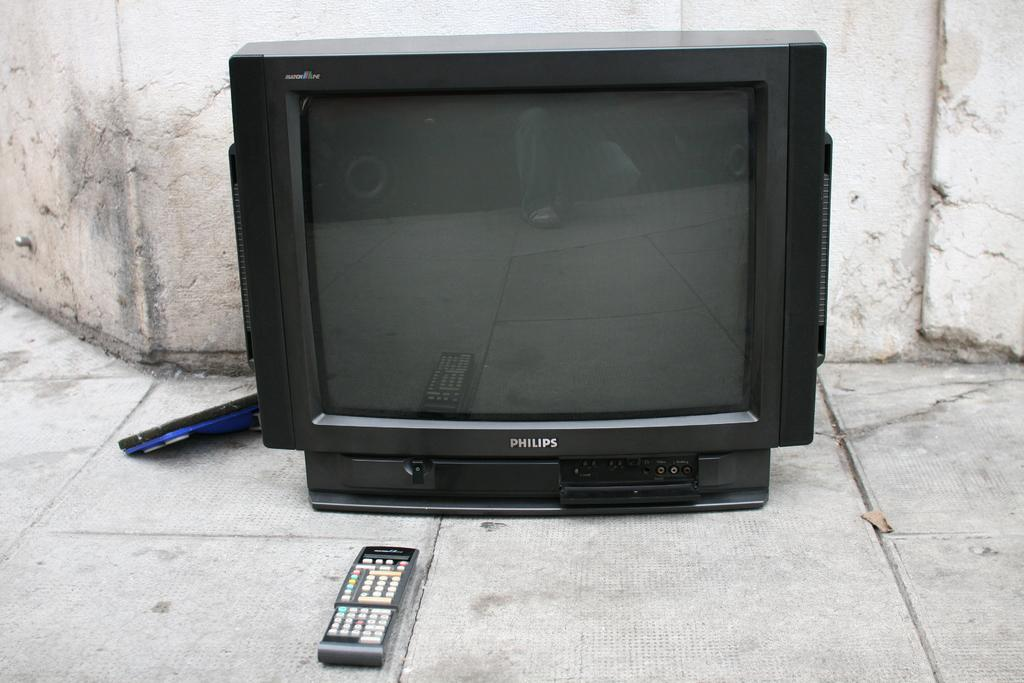<image>
Offer a succinct explanation of the picture presented. A MATCHLINE PHILIPS TV is on the ground with the remote in front of it. 